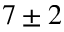<formula> <loc_0><loc_0><loc_500><loc_500>7 \pm 2</formula> 